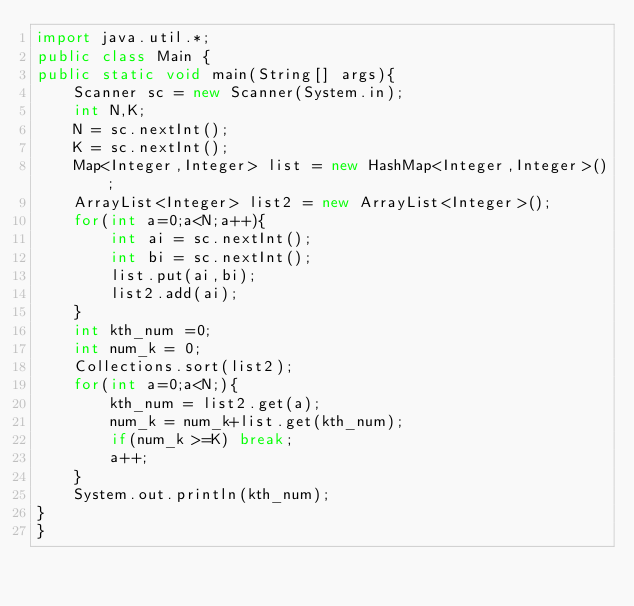Convert code to text. <code><loc_0><loc_0><loc_500><loc_500><_Java_>import java.util.*;
public class Main {
public static void main(String[] args){
    Scanner sc = new Scanner(System.in);
    int N,K;
    N = sc.nextInt();
    K = sc.nextInt();
    Map<Integer,Integer> list = new HashMap<Integer,Integer>();
    ArrayList<Integer> list2 = new ArrayList<Integer>();
    for(int a=0;a<N;a++){
        int ai = sc.nextInt();
        int bi = sc.nextInt();
        list.put(ai,bi);
        list2.add(ai);
    }
    int kth_num =0;
    int num_k = 0;
    Collections.sort(list2);
    for(int a=0;a<N;){
        kth_num = list2.get(a);
        num_k = num_k+list.get(kth_num);
        if(num_k >=K) break;
        a++;
    }
    System.out.println(kth_num);
}
}</code> 